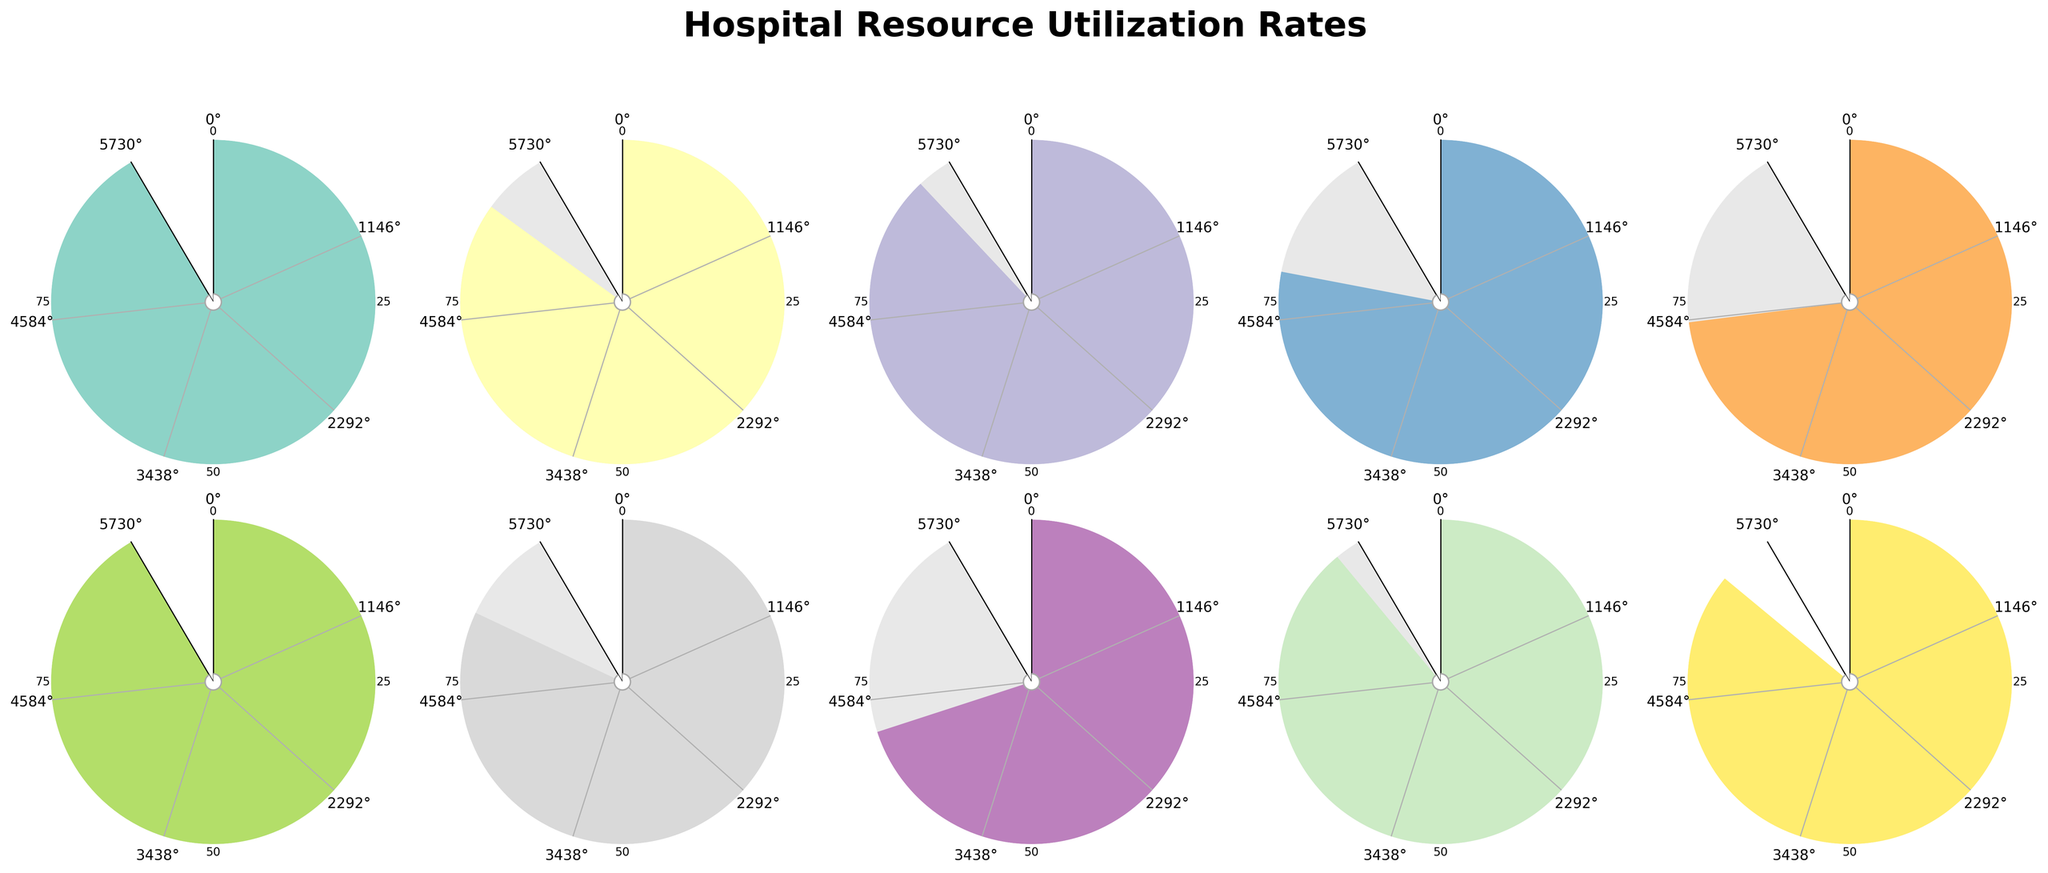What is the title of the figure? The title is prominently displayed at the top of the figure. It provides a clear summary of what the entire figure is about, related to hospital resources.
Answer: Hospital Resource Utilization Rates Which hospital resource has the highest utilization rate? By visually inspecting each gauge chart, we look for the one with the highest value indicated. The text inside the chart also gives the exact percentage.
Answer: Nursing Staff What is the utilization rate for the Emergency Room? Locate the gauge chart for the Emergency Room. The utilization rate is indicated both by the gauge needle and in text inside the chart.
Answer: 92% How many hospital resources have utilization rates above 80%? We count the number of gauge charts where the utilization rate is above the 80% mark, based on the visual needle position and the text inside the chart.
Answer: 8 What is the median utilization rate of all hospital resources? First, list all utilization rates: 92, 85, 88, 78, 73, 95, 82, 70, 89, 86. Next, order them: 70, 73, 78, 82, 85, 86, 88, 89, 92, 95. The median value in this ordered list is the average of the 5th and 6th values: (85 + 86)/2 = 85.5.
Answer: 85.5 Which resource has the lowest utilization rate and what is it? Find the needle position and text for all resources to identify the lowest rate.
Answer: Blood Bank, 70% How does the utilization rate of ICU Beds compare to Operating Rooms? Compare the rates by examining the gauges for both resources. The ICU Beds utilization rate is 88%, and the Operating Rooms utilization rate is 85%.
Answer: ICU Beds is greater than Operating Rooms If you were to average the utilization rates of CT Scanners, MRI Machines, and Laboratory Services, what would you get? Add the utilization rates: 78 (CT Scanners) + 73 (MRI Machines) + 82 (Laboratory Services) = 233. Then, divide by the number of items (3): 233/3 = 77.67.
Answer: 77.67 What color represents the highest utilization rate on any of the gauges? Look for the color on the chart with the highest utilization rate. Nursing Staff has the highest rate of 95%. The gauge for this resource will indicate the corresponding color.
Answer: Dark grey/Crimson (color at 95% mark) What resource utilization rate is closest to the average utilization rate of all resources? First, calculate the average of all rates: (92+85+88+78+73+95+82+70+89+86)/10 = 83.8. Then, find the rate closest to this value. 82 (Laboratory Services) is the closest.
Answer: 82 (Laboratory Services) What percentage scale is used in the gauges? Inspect the gauges to see the percentage scale markings. The gauges have markings at 0%, 25%, 50%, 75%, and 100%.
Answer: 0% to 100% with increments of 25% 